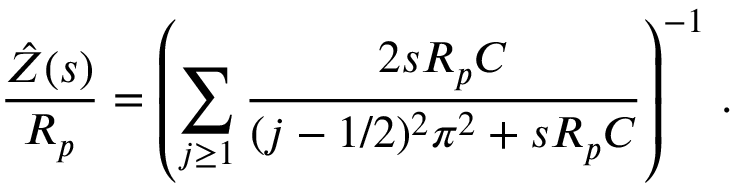Convert formula to latex. <formula><loc_0><loc_0><loc_500><loc_500>\frac { \hat { Z } ( s ) } { R _ { p } } = \left ( \sum _ { j \geq 1 } \frac { 2 s R _ { p } C } { ( j - 1 / 2 ) ^ { 2 } \pi ^ { 2 } + s R _ { p } C } \right ) ^ { - 1 } \, .</formula> 